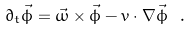<formula> <loc_0><loc_0><loc_500><loc_500>\partial _ { t } \vec { \phi } = \vec { \omega } \times \vec { \phi } - { v } \cdot \nabla \vec { \phi } \ .</formula> 